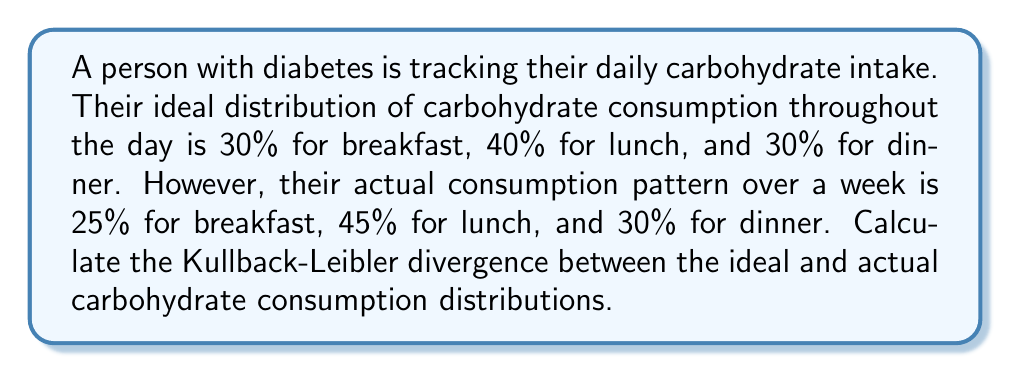Can you answer this question? To solve this problem, we'll use the Kullback-Leibler (KL) divergence formula:

$$D_{KL}(P||Q) = \sum_{i} P(i) \log\left(\frac{P(i)}{Q(i)}\right)$$

Where:
$P(i)$ is the ideal distribution
$Q(i)$ is the actual distribution

Let's define our distributions:

Ideal (P):
$P(\text{breakfast}) = 0.30$
$P(\text{lunch}) = 0.40$
$P(\text{dinner}) = 0.30$

Actual (Q):
$Q(\text{breakfast}) = 0.25$
$Q(\text{lunch}) = 0.45$
$Q(\text{dinner}) = 0.30$

Now, let's calculate each term of the sum:

1. For breakfast:
   $0.30 \log\left(\frac{0.30}{0.25}\right) = 0.30 \log(1.2) = 0.30 \cdot 0.0792 = 0.02376$

2. For lunch:
   $0.40 \log\left(\frac{0.40}{0.45}\right) = 0.40 \log(0.8889) = 0.40 \cdot (-0.1178) = -0.04712$

3. For dinner:
   $0.30 \log\left(\frac{0.30}{0.30}\right) = 0.30 \log(1) = 0$

Sum up all terms:
$D_{KL}(P||Q) = 0.02376 + (-0.04712) + 0 = -0.02336$

The negative result indicates that the actual distribution is slightly more spread out than the ideal distribution.
Answer: The Kullback-Leibler divergence between the ideal and actual carbohydrate consumption distributions is approximately $-0.02336$ nats. 